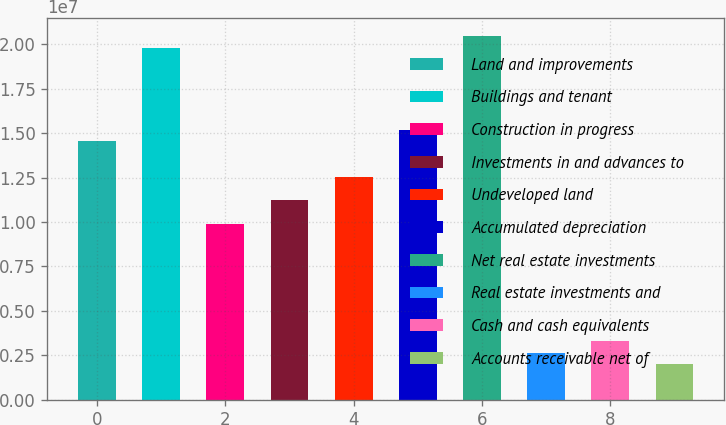<chart> <loc_0><loc_0><loc_500><loc_500><bar_chart><fcel>Land and improvements<fcel>Buildings and tenant<fcel>Construction in progress<fcel>Investments in and advances to<fcel>Undeveloped land<fcel>Accumulated depreciation<fcel>Net real estate investments<fcel>Real estate investments and<fcel>Cash and cash equivalents<fcel>Accounts receivable net of<nl><fcel>1.45365e+07<fcel>1.98222e+07<fcel>9.91153e+06<fcel>1.1233e+07<fcel>1.25544e+07<fcel>1.51972e+07<fcel>2.0483e+07<fcel>2.64367e+06<fcel>3.30438e+06<fcel>1.98295e+06<nl></chart> 